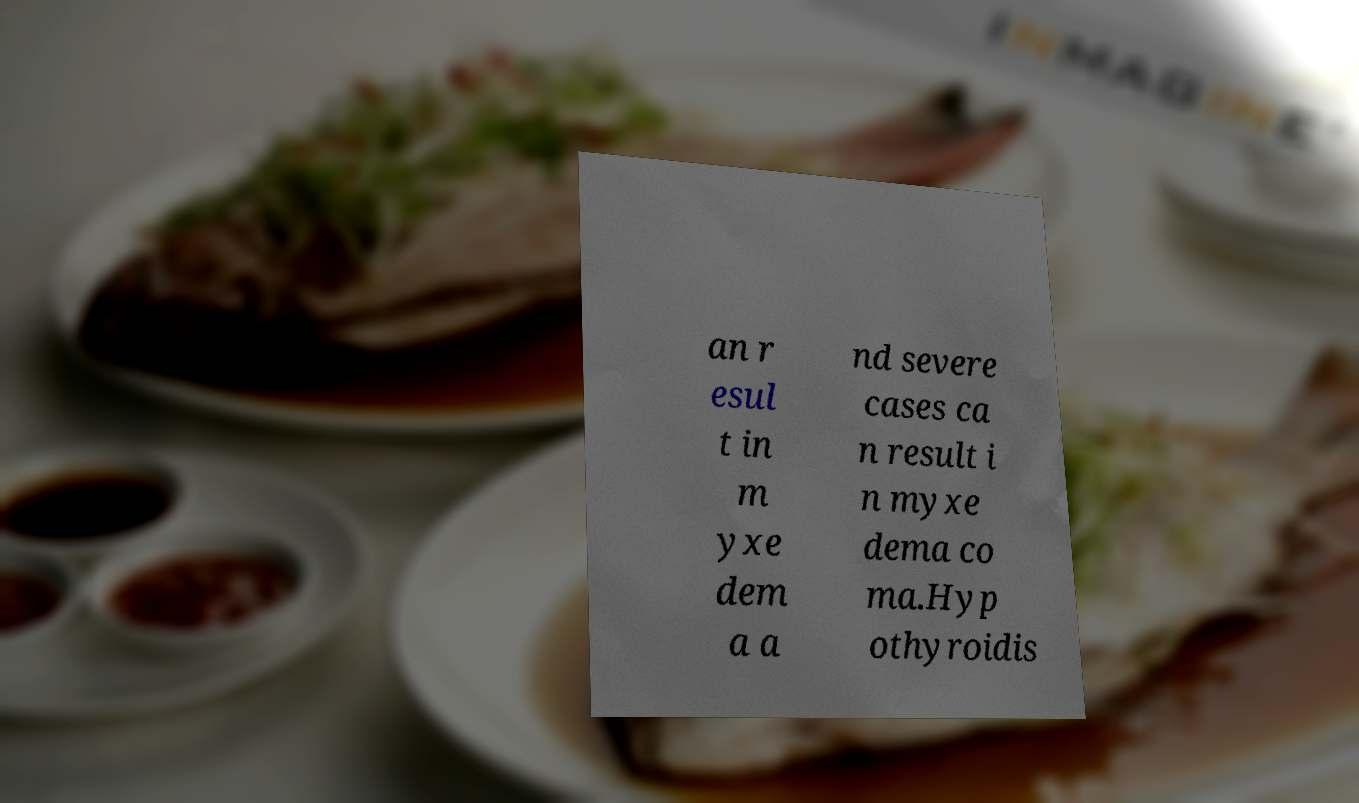What messages or text are displayed in this image? I need them in a readable, typed format. an r esul t in m yxe dem a a nd severe cases ca n result i n myxe dema co ma.Hyp othyroidis 